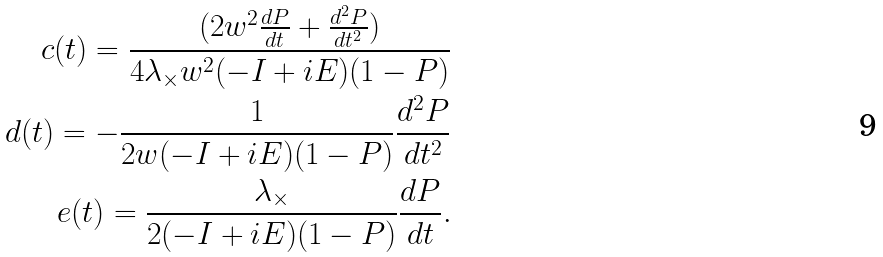<formula> <loc_0><loc_0><loc_500><loc_500>c ( t ) = \frac { ( 2 w ^ { 2 } \frac { d P } { d t } + \frac { d ^ { 2 } P } { d t ^ { 2 } } ) } { 4 \lambda _ { \times } w ^ { 2 } ( - I + i E ) ( 1 - P ) } \\ d ( t ) = - \frac { 1 } { 2 w ( - I + i E ) ( 1 - P ) } \frac { d ^ { 2 } P } { d t ^ { 2 } } \\ e ( t ) = \frac { \lambda _ { \times } } { 2 ( - I + i E ) ( 1 - P ) } \frac { d P } { d t } .</formula> 